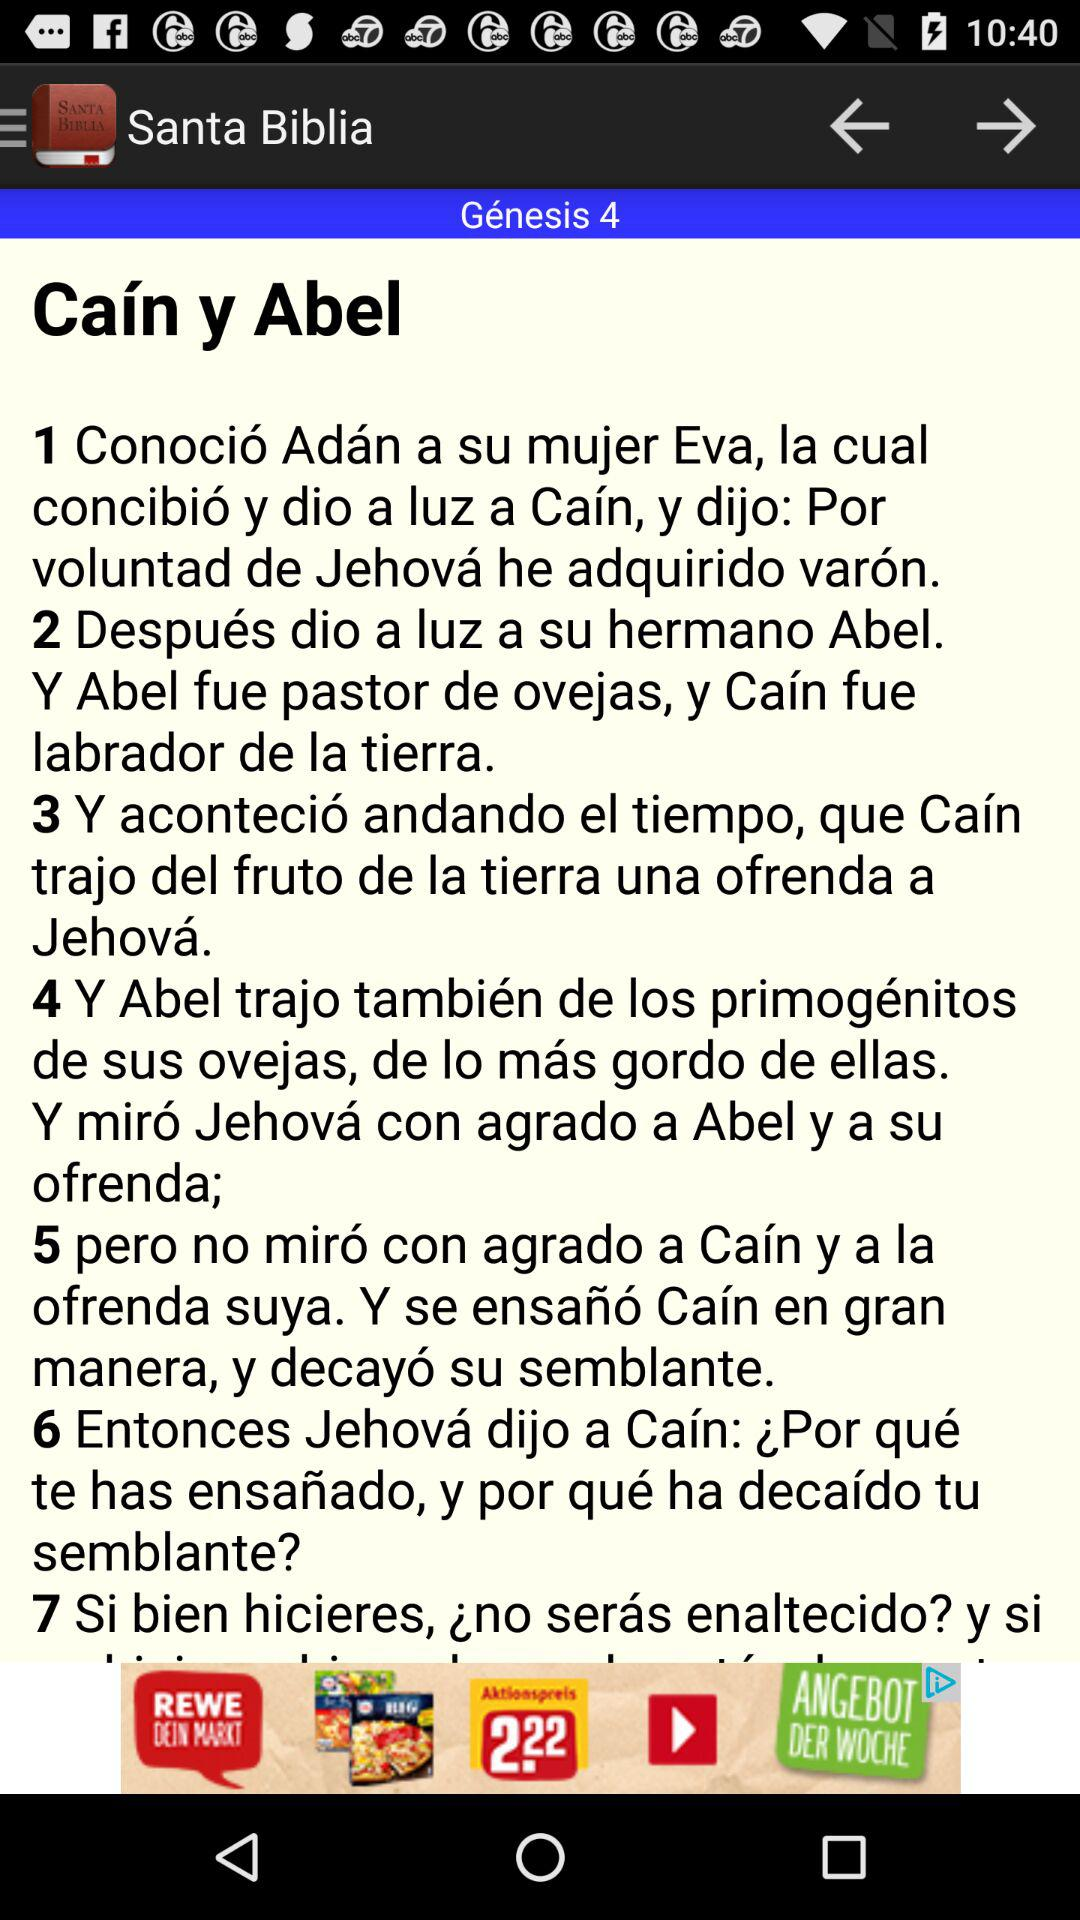How many verses are there in the passage?
Answer the question using a single word or phrase. 7 